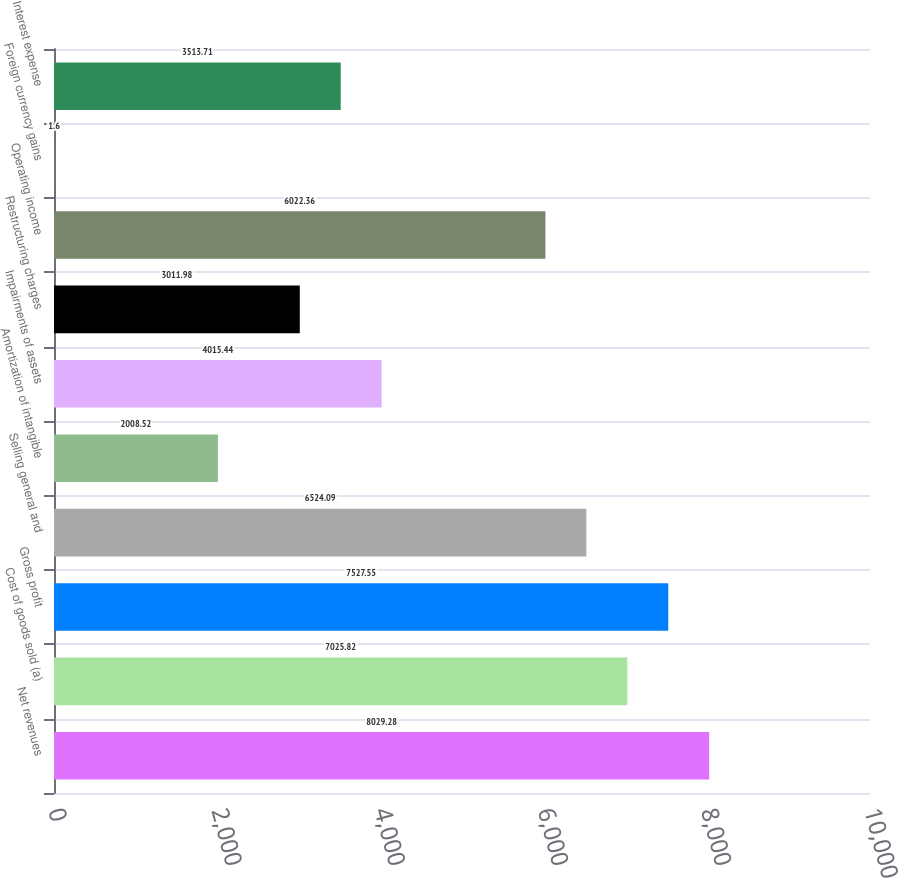Convert chart to OTSL. <chart><loc_0><loc_0><loc_500><loc_500><bar_chart><fcel>Net revenues<fcel>Cost of goods sold (a)<fcel>Gross profit<fcel>Selling general and<fcel>Amortization of intangible<fcel>Impairments of assets<fcel>Restructuring charges<fcel>Operating income<fcel>Foreign currency gains<fcel>Interest expense<nl><fcel>8029.28<fcel>7025.82<fcel>7527.55<fcel>6524.09<fcel>2008.52<fcel>4015.44<fcel>3011.98<fcel>6022.36<fcel>1.6<fcel>3513.71<nl></chart> 